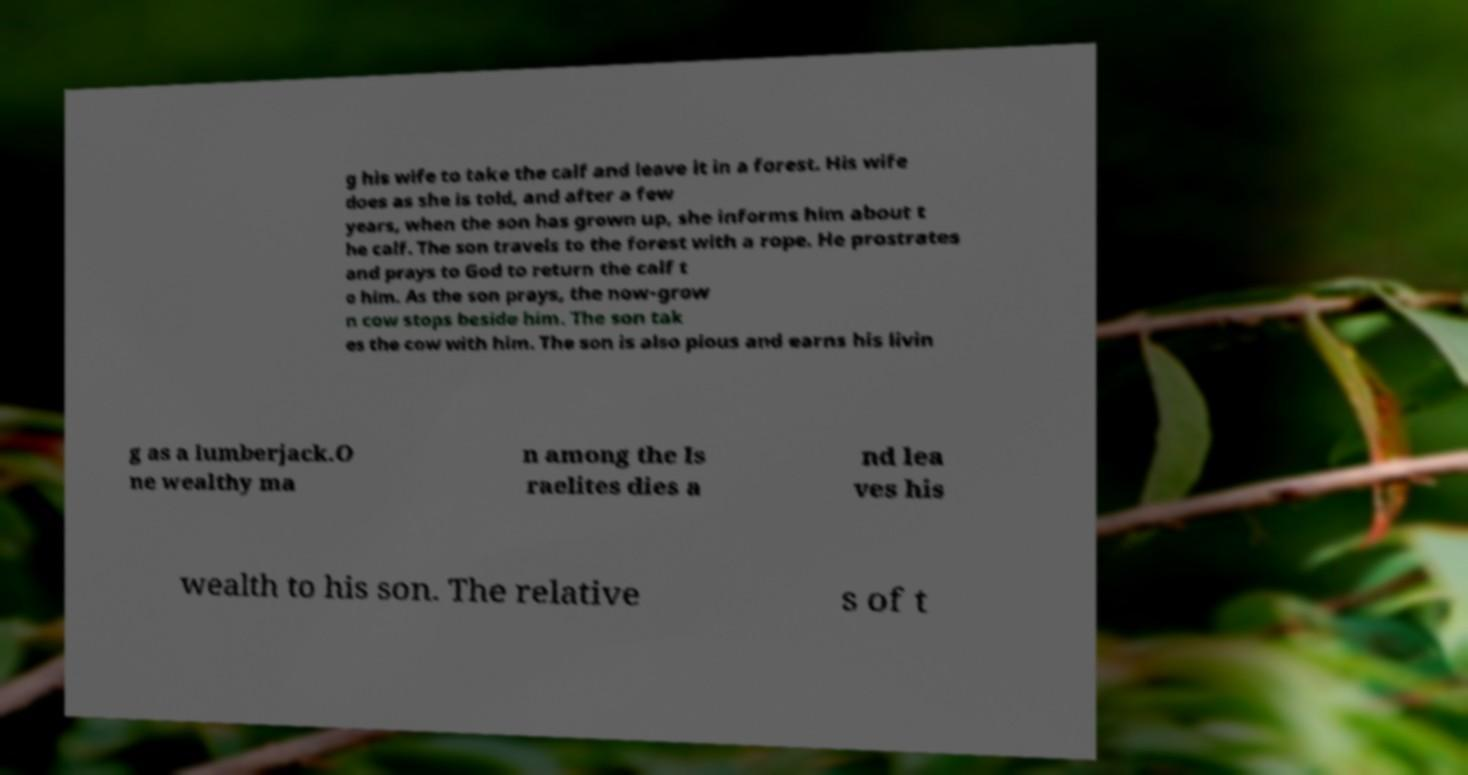Can you read and provide the text displayed in the image?This photo seems to have some interesting text. Can you extract and type it out for me? g his wife to take the calf and leave it in a forest. His wife does as she is told, and after a few years, when the son has grown up, she informs him about t he calf. The son travels to the forest with a rope. He prostrates and prays to God to return the calf t o him. As the son prays, the now-grow n cow stops beside him. The son tak es the cow with him. The son is also pious and earns his livin g as a lumberjack.O ne wealthy ma n among the Is raelites dies a nd lea ves his wealth to his son. The relative s of t 